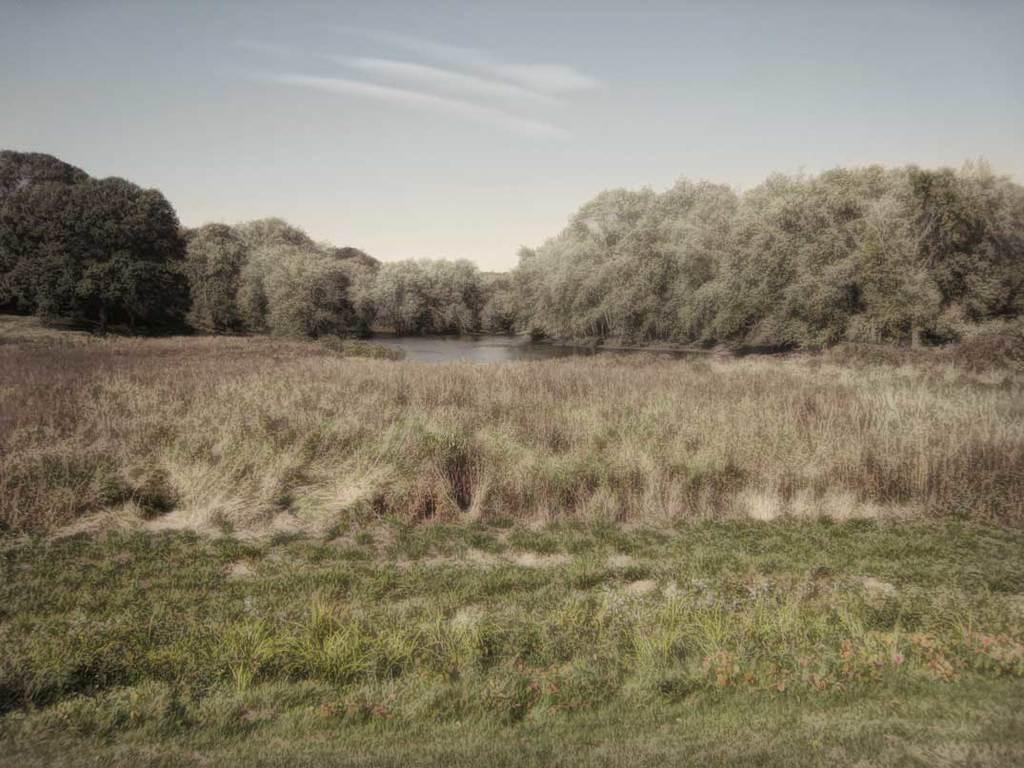Can you describe this image briefly? In this image we can see land full of grass. Behind it one lake is there, around the lake many trees are present. 